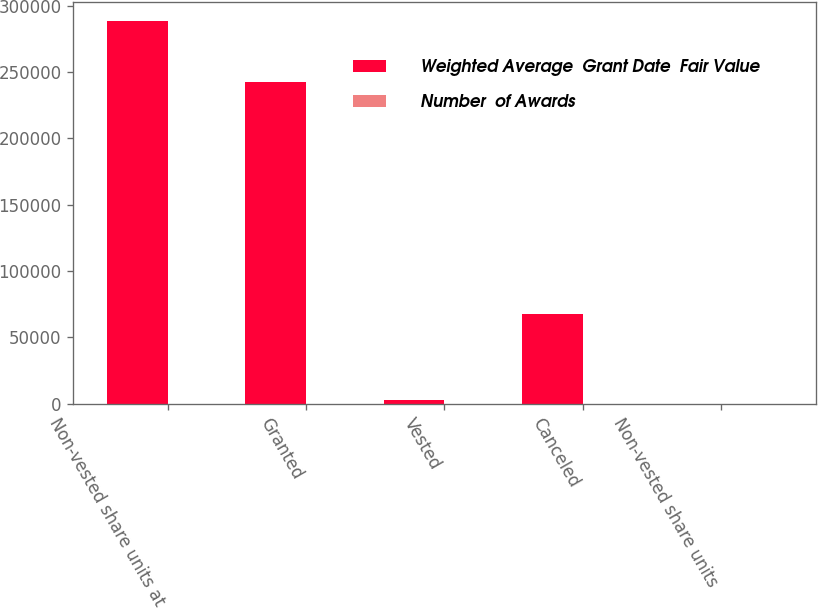Convert chart. <chart><loc_0><loc_0><loc_500><loc_500><stacked_bar_chart><ecel><fcel>Non-vested share units at<fcel>Granted<fcel>Vested<fcel>Canceled<fcel>Non-vested share units<nl><fcel>Weighted Average  Grant Date  Fair Value<fcel>288493<fcel>242352<fcel>3021<fcel>67895<fcel>41.79<nl><fcel>Number  of Awards<fcel>30.78<fcel>35.98<fcel>41.79<fcel>38.13<fcel>32.36<nl></chart> 